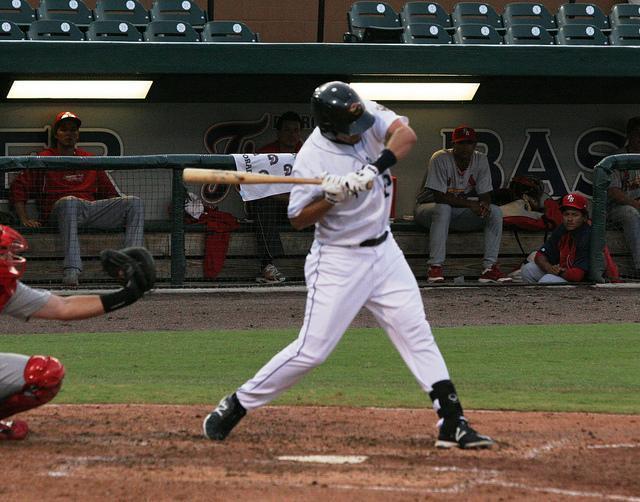How many chairs are there?
Give a very brief answer. 2. How many people are in the picture?
Give a very brief answer. 8. 